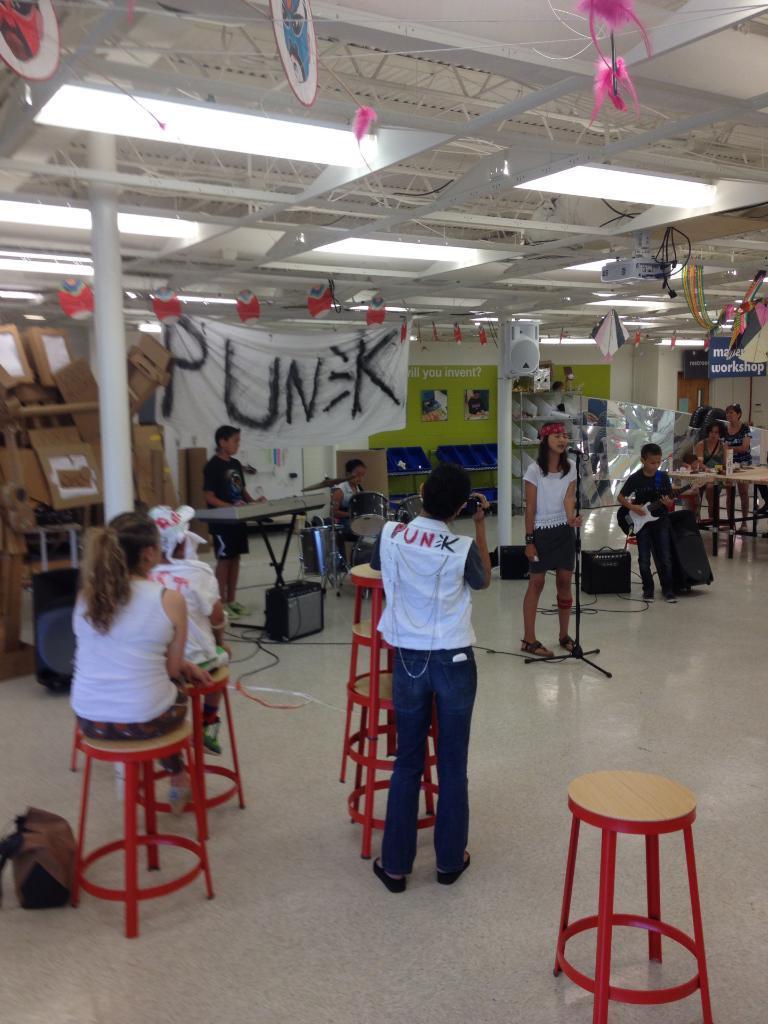Could you give a brief overview of what you see in this image? In this picture we can see a group of people where some are sitting and some are standing and playing musical instruments such as drums, piano, guitar and a woman is singing on mic and in the background we can see a banner, boxes, lights. 